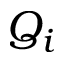Convert formula to latex. <formula><loc_0><loc_0><loc_500><loc_500>Q _ { i }</formula> 